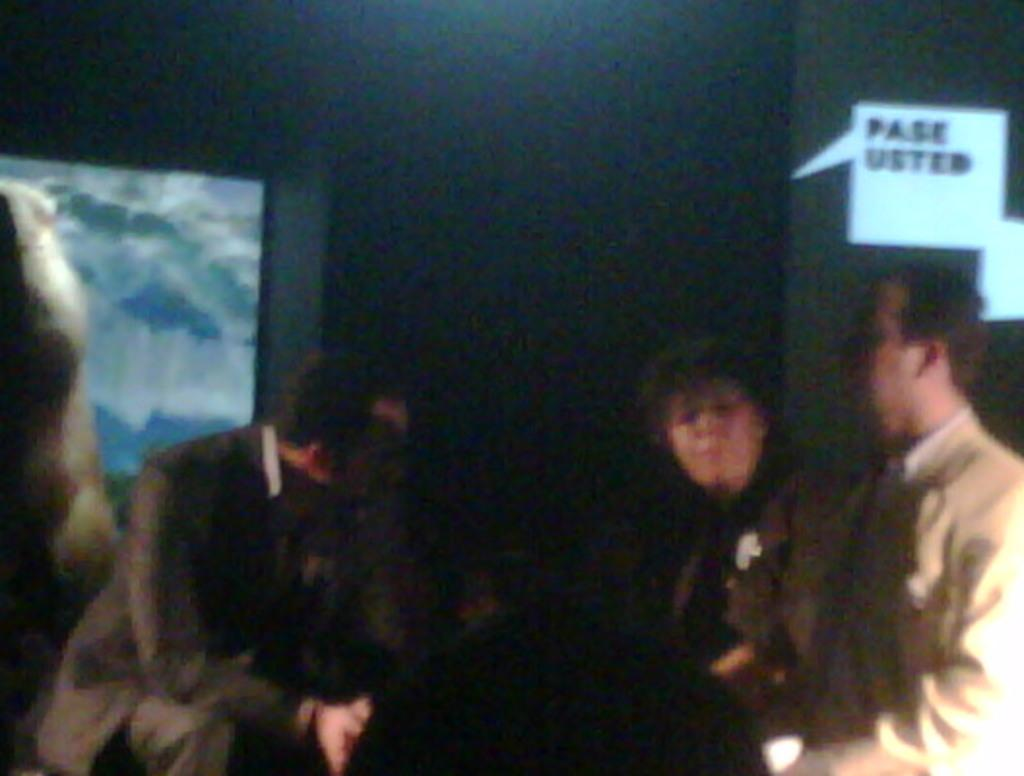How many people are in the image? There is a group of persons in the image. What are the people in the image doing? The persons are standing. What color is the sheet in the background of the image? There is a black color sheet in the background of the image. What type of watch is the person wearing in the image? There is no watch visible on any person in the image. 